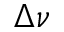<formula> <loc_0><loc_0><loc_500><loc_500>\Delta \nu</formula> 